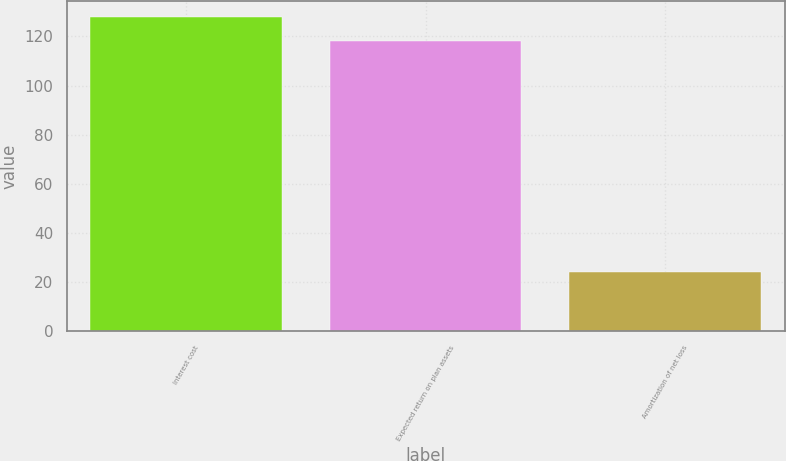Convert chart. <chart><loc_0><loc_0><loc_500><loc_500><bar_chart><fcel>Interest cost<fcel>Expected return on plan assets<fcel>Amortization of net loss<nl><fcel>128<fcel>118<fcel>24<nl></chart> 